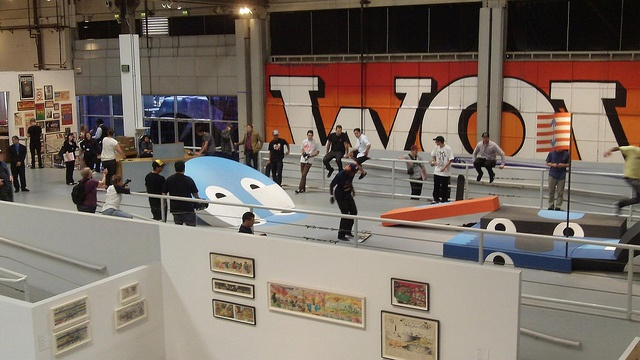Describe the objects in this image and their specific colors. I can see people in maroon, black, gray, and darkgray tones, people in maroon, black, and gray tones, people in maroon, black, gray, and darkgray tones, people in maroon, black, darkgray, and gray tones, and people in maroon, black, gray, and darkgray tones in this image. 